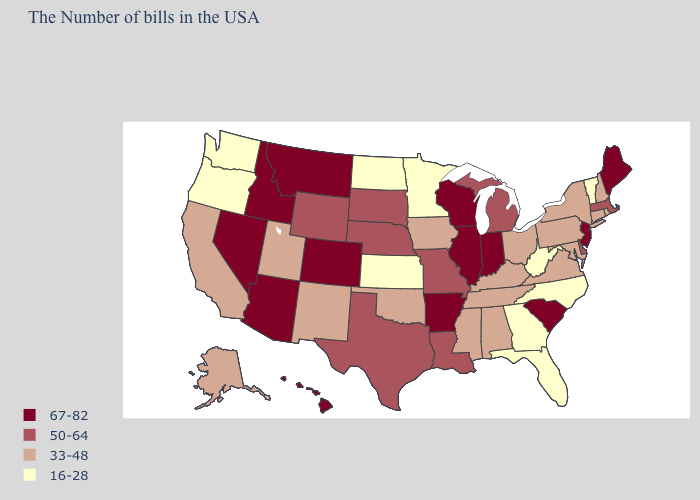What is the value of Tennessee?
Give a very brief answer. 33-48. What is the value of Rhode Island?
Answer briefly. 33-48. What is the value of Arkansas?
Give a very brief answer. 67-82. How many symbols are there in the legend?
Concise answer only. 4. Name the states that have a value in the range 67-82?
Answer briefly. Maine, New Jersey, South Carolina, Indiana, Wisconsin, Illinois, Arkansas, Colorado, Montana, Arizona, Idaho, Nevada, Hawaii. Which states have the lowest value in the USA?
Concise answer only. Vermont, North Carolina, West Virginia, Florida, Georgia, Minnesota, Kansas, North Dakota, Washington, Oregon. What is the lowest value in states that border New Jersey?
Write a very short answer. 33-48. Does Arizona have a higher value than Arkansas?
Write a very short answer. No. What is the value of New Hampshire?
Be succinct. 33-48. Does the first symbol in the legend represent the smallest category?
Answer briefly. No. Name the states that have a value in the range 50-64?
Write a very short answer. Massachusetts, Delaware, Michigan, Louisiana, Missouri, Nebraska, Texas, South Dakota, Wyoming. Among the states that border Florida , which have the lowest value?
Keep it brief. Georgia. Name the states that have a value in the range 50-64?
Short answer required. Massachusetts, Delaware, Michigan, Louisiana, Missouri, Nebraska, Texas, South Dakota, Wyoming. Name the states that have a value in the range 67-82?
Write a very short answer. Maine, New Jersey, South Carolina, Indiana, Wisconsin, Illinois, Arkansas, Colorado, Montana, Arizona, Idaho, Nevada, Hawaii. Does Arkansas have the highest value in the USA?
Short answer required. Yes. 